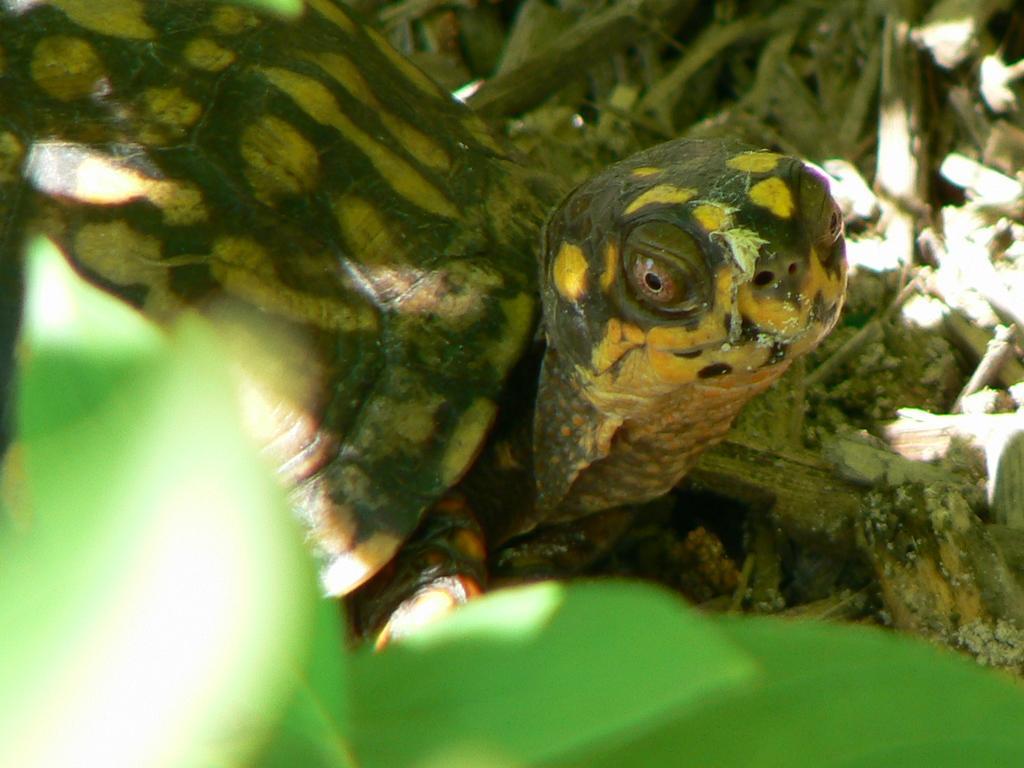Please provide a concise description of this image. Here in this picture we can see a close up view of a tortoise present on the ground and we can see grass present on the ground and in the front we can see leaves in blurry manner. 